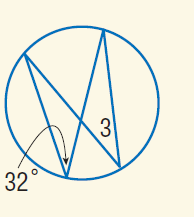Question: Find m \angle 3.
Choices:
A. 32
B. 64
C. 128
D. 148
Answer with the letter. Answer: A 